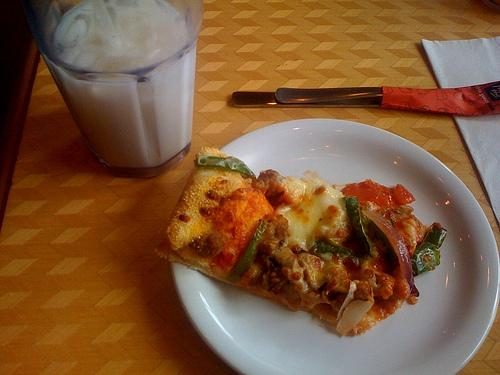How has this food been prepared for serving?

Choices:
A) grated
B) scooped
C) sliced
D) poured sliced 